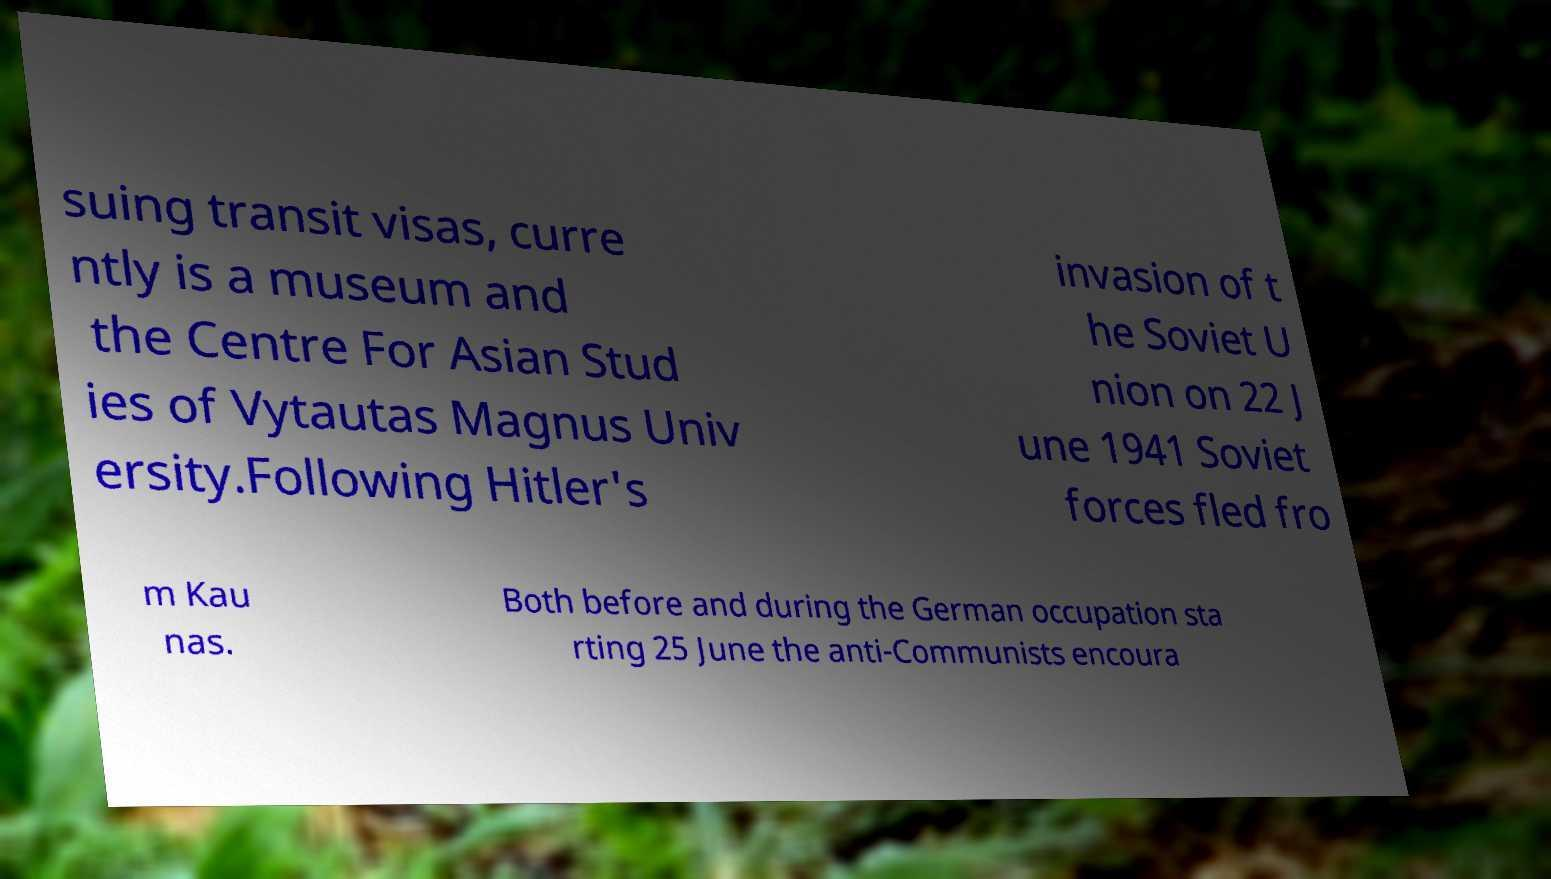There's text embedded in this image that I need extracted. Can you transcribe it verbatim? suing transit visas, curre ntly is a museum and the Centre For Asian Stud ies of Vytautas Magnus Univ ersity.Following Hitler's invasion of t he Soviet U nion on 22 J une 1941 Soviet forces fled fro m Kau nas. Both before and during the German occupation sta rting 25 June the anti-Communists encoura 